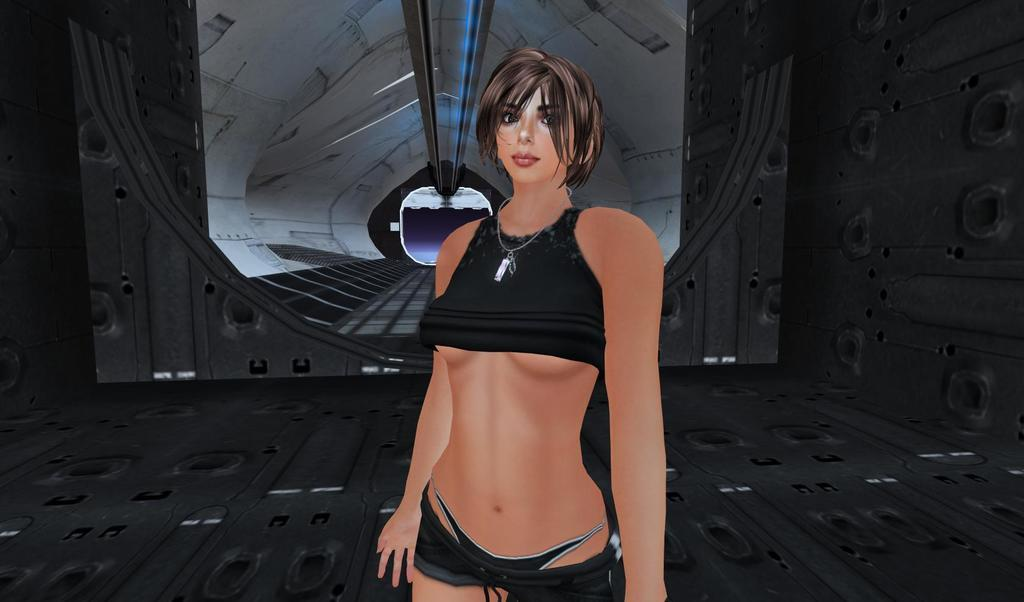What type of image is being described? The image is an animated picture. Can you describe the person in the image? There is a person standing in the image. What else can be seen in the image besides the person? There is an animated object behind the person in the image. What invention does the person in the image use to embark on their journey? There is no mention of an invention or journey in the image, as it only features a person standing in front of an animated object. 